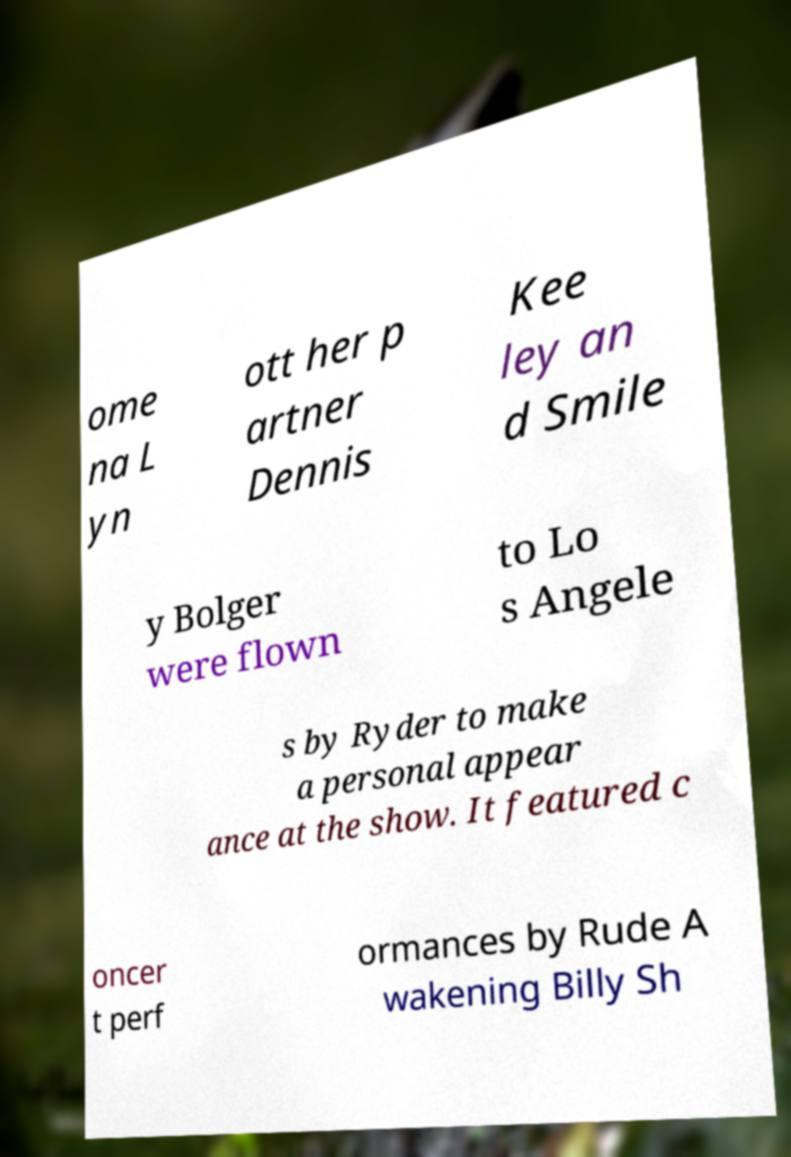Can you read and provide the text displayed in the image?This photo seems to have some interesting text. Can you extract and type it out for me? ome na L yn ott her p artner Dennis Kee ley an d Smile y Bolger were flown to Lo s Angele s by Ryder to make a personal appear ance at the show. It featured c oncer t perf ormances by Rude A wakening Billy Sh 